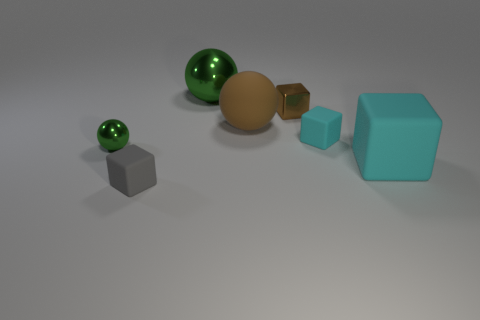How big is the gray matte object?
Make the answer very short. Small. What number of brown metal blocks are the same size as the gray matte thing?
Keep it short and to the point. 1. What is the material of the small cyan thing that is the same shape as the tiny gray thing?
Your response must be concise. Rubber. There is a matte object that is in front of the tiny cyan cube and behind the gray object; what is its shape?
Your answer should be compact. Cube. There is a small rubber thing that is behind the large matte cube; what is its shape?
Ensure brevity in your answer.  Cube. What number of objects are both on the left side of the big cyan thing and in front of the brown block?
Keep it short and to the point. 4. Is the size of the brown rubber sphere the same as the cyan matte object that is on the left side of the big cyan matte object?
Offer a terse response. No. What size is the green shiny ball left of the tiny rubber block that is on the left side of the small brown metallic object behind the small green metal object?
Give a very brief answer. Small. How big is the green metal ball in front of the big green shiny sphere?
Ensure brevity in your answer.  Small. What shape is the brown thing that is the same material as the small gray cube?
Your response must be concise. Sphere. 